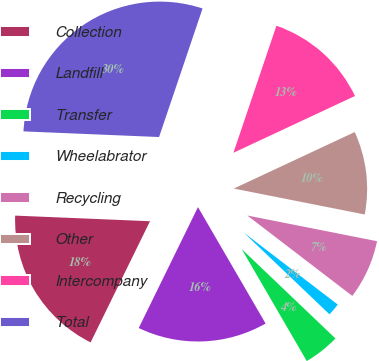Convert chart. <chart><loc_0><loc_0><loc_500><loc_500><pie_chart><fcel>Collection<fcel>Landfill<fcel>Transfer<fcel>Wheelabrator<fcel>Recycling<fcel>Other<fcel>Intercompany<fcel>Total<nl><fcel>18.41%<fcel>15.63%<fcel>4.5%<fcel>1.72%<fcel>7.29%<fcel>10.07%<fcel>12.85%<fcel>29.53%<nl></chart> 